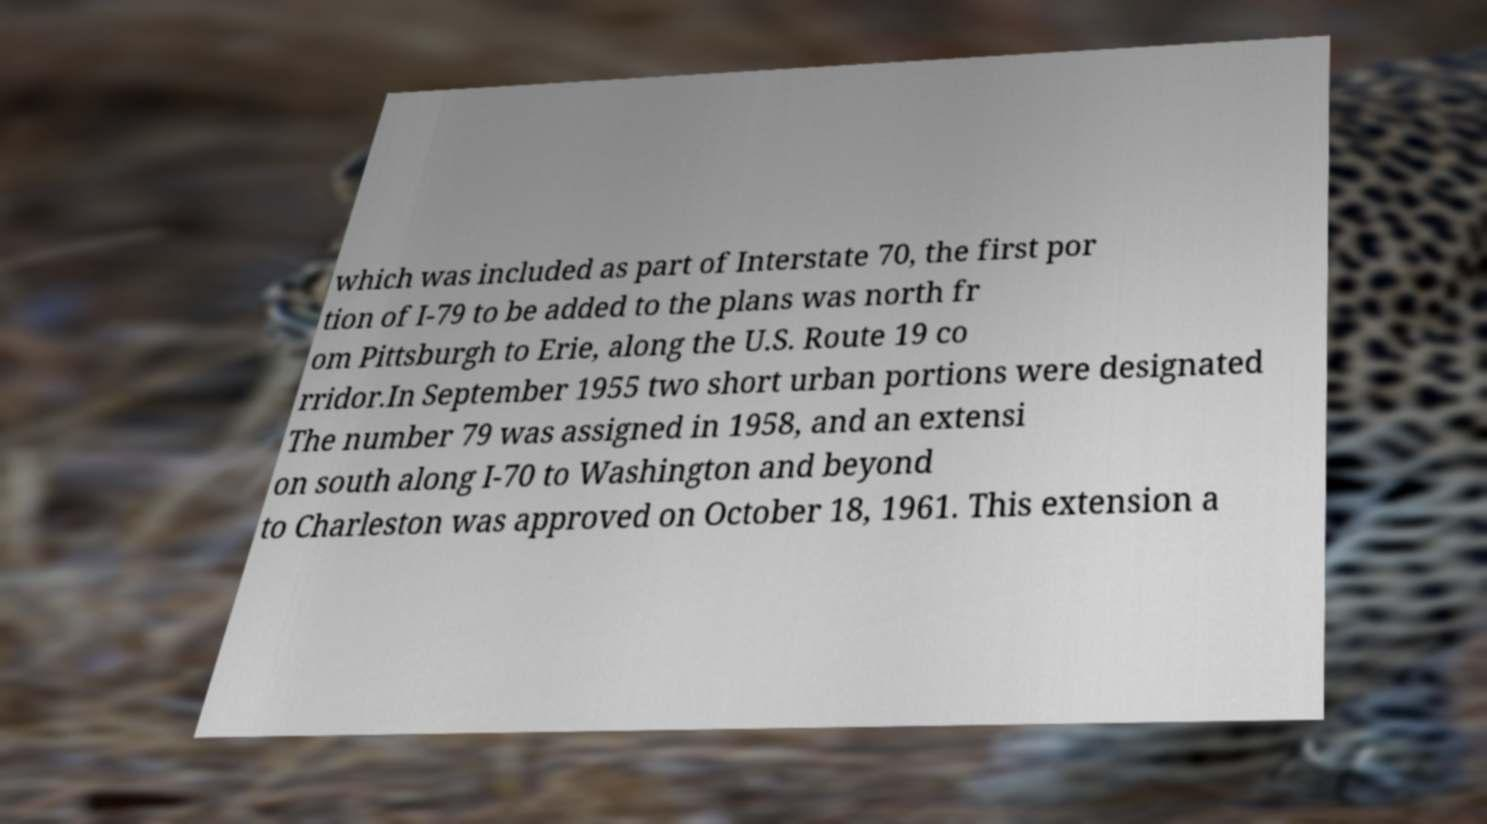Could you extract and type out the text from this image? which was included as part of Interstate 70, the first por tion of I-79 to be added to the plans was north fr om Pittsburgh to Erie, along the U.S. Route 19 co rridor.In September 1955 two short urban portions were designated The number 79 was assigned in 1958, and an extensi on south along I-70 to Washington and beyond to Charleston was approved on October 18, 1961. This extension a 